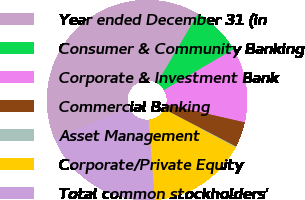<chart> <loc_0><loc_0><loc_500><loc_500><pie_chart><fcel>Year ended December 31 (in<fcel>Consumer & Community Banking<fcel>Corporate & Investment Bank<fcel>Commercial Banking<fcel>Asset Management<fcel>Corporate/Private Equity<fcel>Total common stockholders'<nl><fcel>39.75%<fcel>8.06%<fcel>12.02%<fcel>4.1%<fcel>0.14%<fcel>15.98%<fcel>19.94%<nl></chart> 